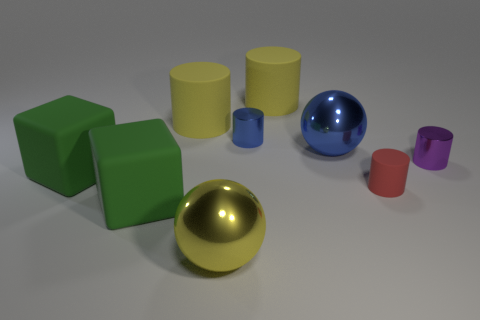Is the size of the metallic cylinder that is behind the tiny purple thing the same as the green rubber object behind the small matte cylinder?
Ensure brevity in your answer.  No. How many objects are big green objects in front of the red rubber cylinder or tiny purple cylinders?
Provide a succinct answer. 2. There is a large sphere in front of the purple metal thing; what is it made of?
Offer a terse response. Metal. What is the material of the yellow sphere?
Offer a terse response. Metal. There is a big sphere to the left of the metal sphere that is to the right of the tiny object that is left of the red cylinder; what is it made of?
Your answer should be compact. Metal. There is a purple metal cylinder; does it have the same size as the matte thing that is on the right side of the blue metal sphere?
Provide a short and direct response. Yes. What number of objects are either blue things that are left of the purple cylinder or big rubber things that are in front of the blue metallic sphere?
Provide a short and direct response. 4. What is the color of the big matte cylinder on the right side of the yellow shiny ball?
Your answer should be compact. Yellow. There is a cylinder right of the red rubber object; is there a blue object that is in front of it?
Make the answer very short. No. Are there fewer small gray rubber blocks than cylinders?
Offer a very short reply. Yes. 